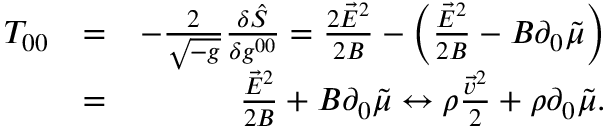Convert formula to latex. <formula><loc_0><loc_0><loc_500><loc_500>\begin{array} { r l r } { T _ { 0 0 } } & { = } & { - \frac { 2 } { \sqrt { - g } } \frac { \delta \hat { S } } { \delta g ^ { 0 0 } } = \frac { 2 \vec { E } ^ { 2 } } { 2 B } - \left ( \frac { \vec { E } ^ { 2 } } { 2 B } - B \partial _ { 0 } \tilde { \mu } \right ) } \\ & { = } & { \frac { \vec { E } ^ { 2 } } { 2 B } + B \partial _ { 0 } \tilde { \mu } \leftrightarrow \rho \frac { \vec { v } ^ { 2 } } { 2 } + \rho \partial _ { 0 } \tilde { \mu } . } \end{array}</formula> 